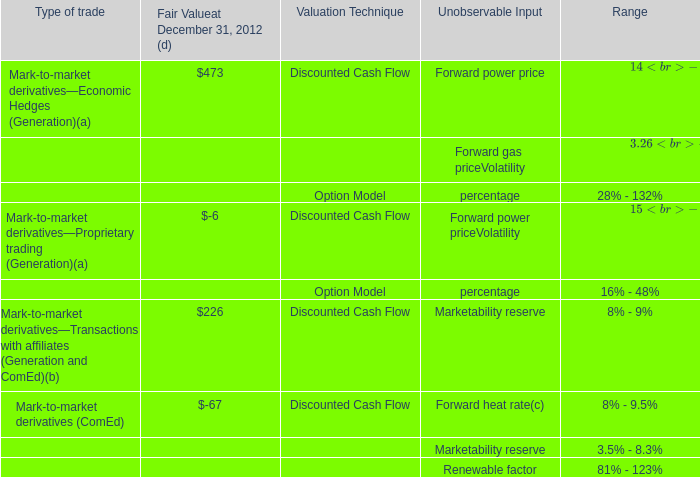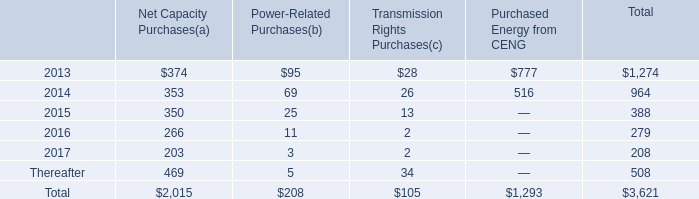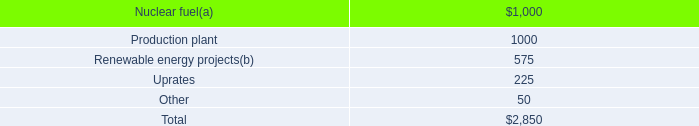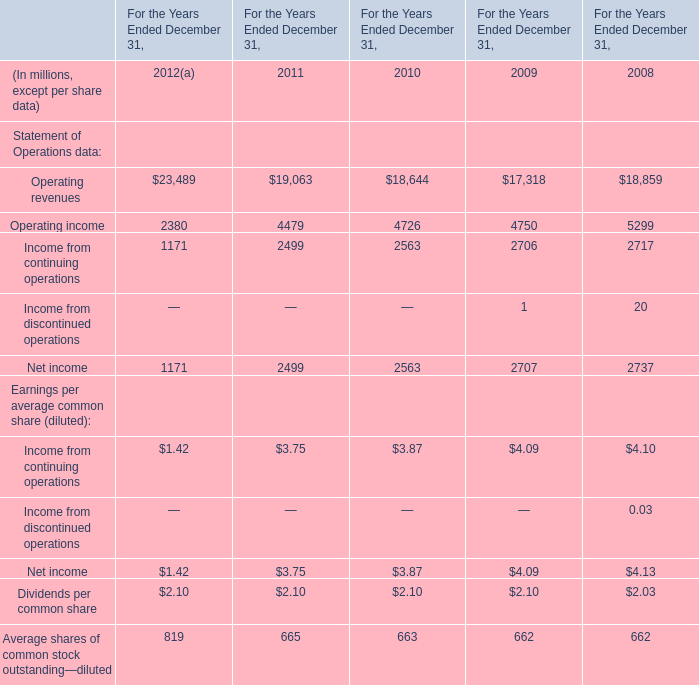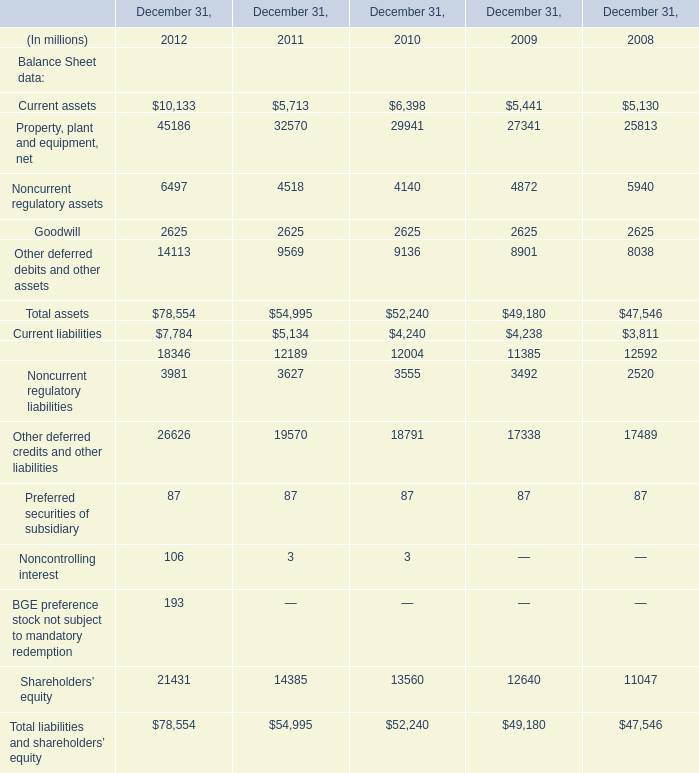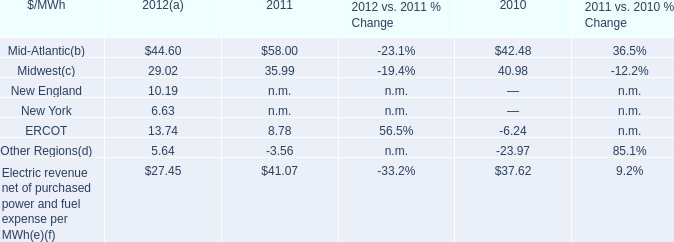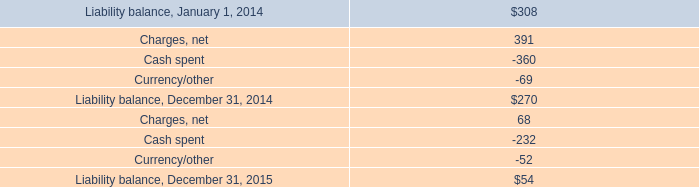What's the sum of Noncurrent regulatory assets of December 31, 2012, Net income of For the Years Ended December 31, 2012, and Current liabilities of December 31, 2008 ? 
Computations: ((6497.0 + 1171.0) + 3811.0)
Answer: 11479.0. 